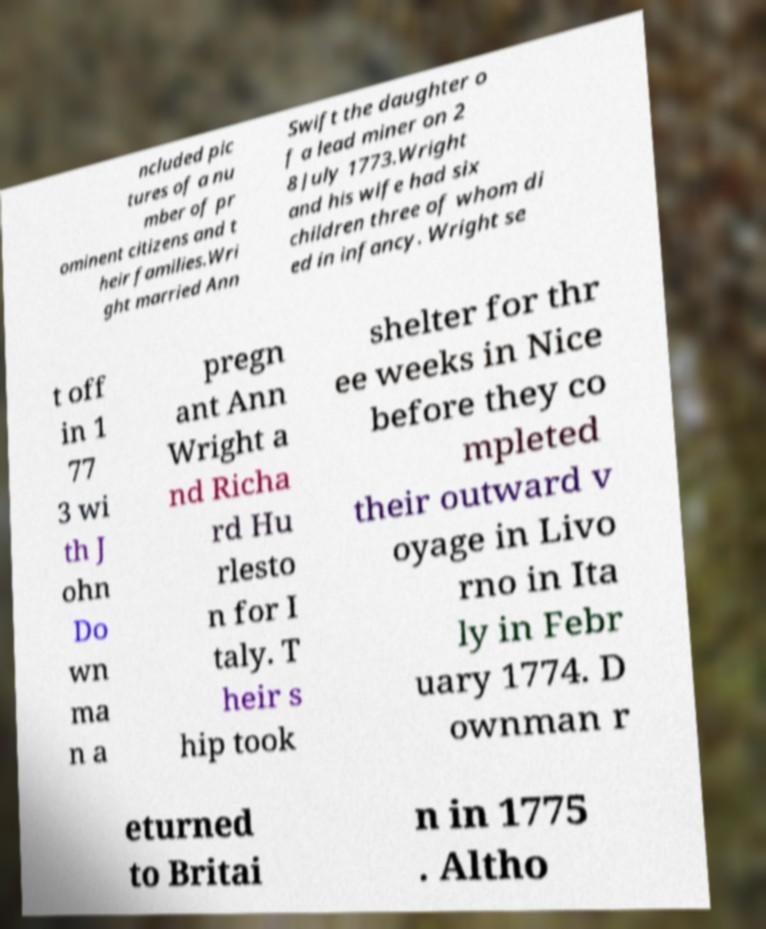There's text embedded in this image that I need extracted. Can you transcribe it verbatim? ncluded pic tures of a nu mber of pr ominent citizens and t heir families.Wri ght married Ann Swift the daughter o f a lead miner on 2 8 July 1773.Wright and his wife had six children three of whom di ed in infancy. Wright se t off in 1 77 3 wi th J ohn Do wn ma n a pregn ant Ann Wright a nd Richa rd Hu rlesto n for I taly. T heir s hip took shelter for thr ee weeks in Nice before they co mpleted their outward v oyage in Livo rno in Ita ly in Febr uary 1774. D ownman r eturned to Britai n in 1775 . Altho 